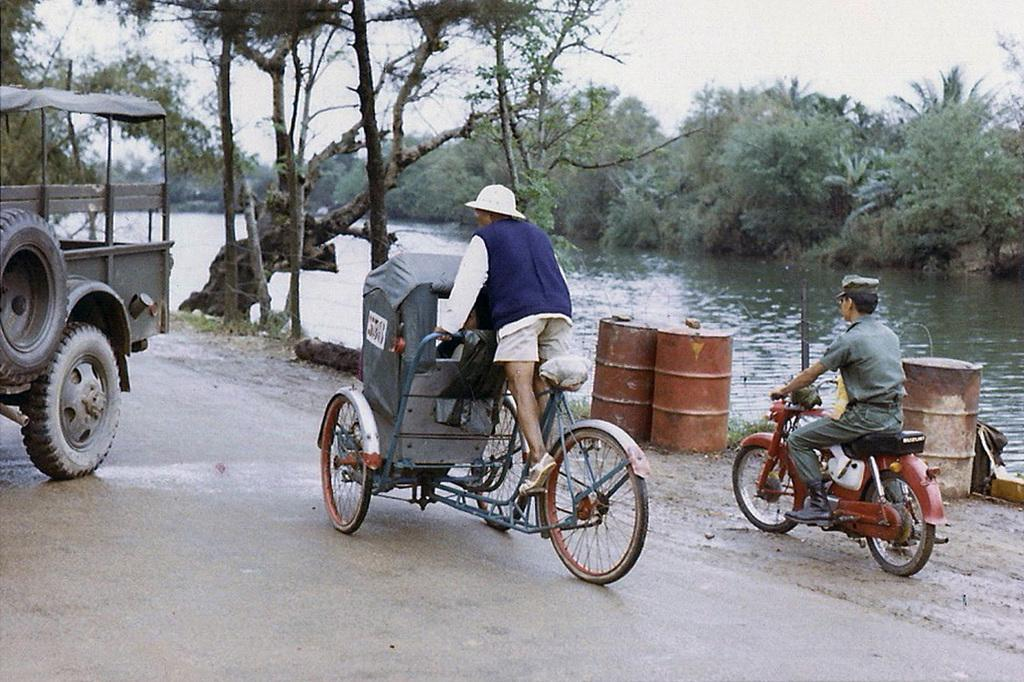What is the main subject of the image? The main subject of the image is a person riding a bicycle in the center of the image. Are there any other vehicles or people in the image? Yes, there is a person riding a motorcycle on the right side of the image. What can be seen in the background of the image? Trees and the sky are visible in the background of the image. What type of store can be seen in the background of the image? There is no store visible in the background of the image; it only features trees and the sky. Can you tell me how many buttons are on the bicycle in the image? There are no buttons present on the bicycle in the image. 